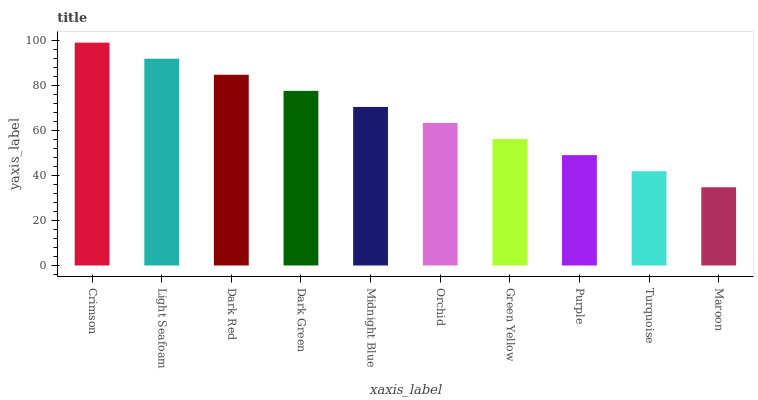Is Maroon the minimum?
Answer yes or no. Yes. Is Crimson the maximum?
Answer yes or no. Yes. Is Light Seafoam the minimum?
Answer yes or no. No. Is Light Seafoam the maximum?
Answer yes or no. No. Is Crimson greater than Light Seafoam?
Answer yes or no. Yes. Is Light Seafoam less than Crimson?
Answer yes or no. Yes. Is Light Seafoam greater than Crimson?
Answer yes or no. No. Is Crimson less than Light Seafoam?
Answer yes or no. No. Is Midnight Blue the high median?
Answer yes or no. Yes. Is Orchid the low median?
Answer yes or no. Yes. Is Crimson the high median?
Answer yes or no. No. Is Crimson the low median?
Answer yes or no. No. 